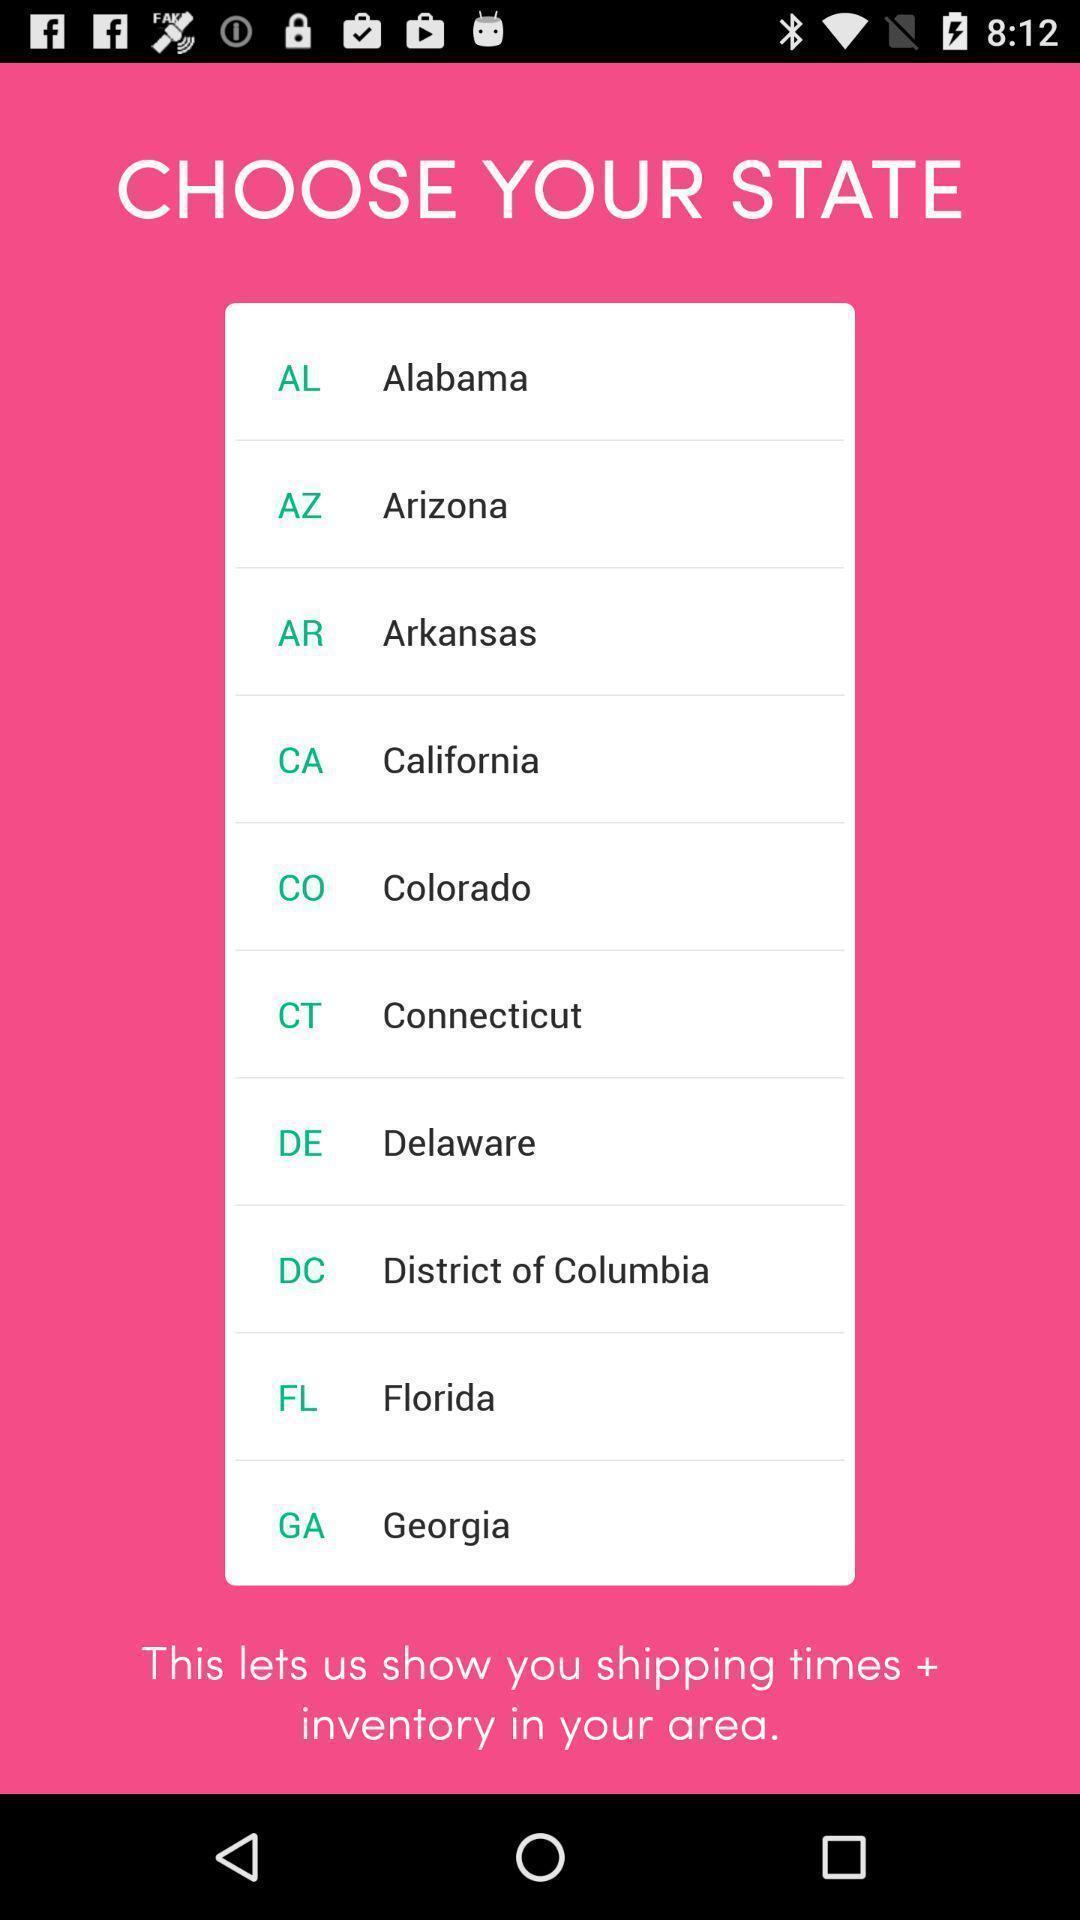Tell me what you see in this picture. State selection option in the application. 